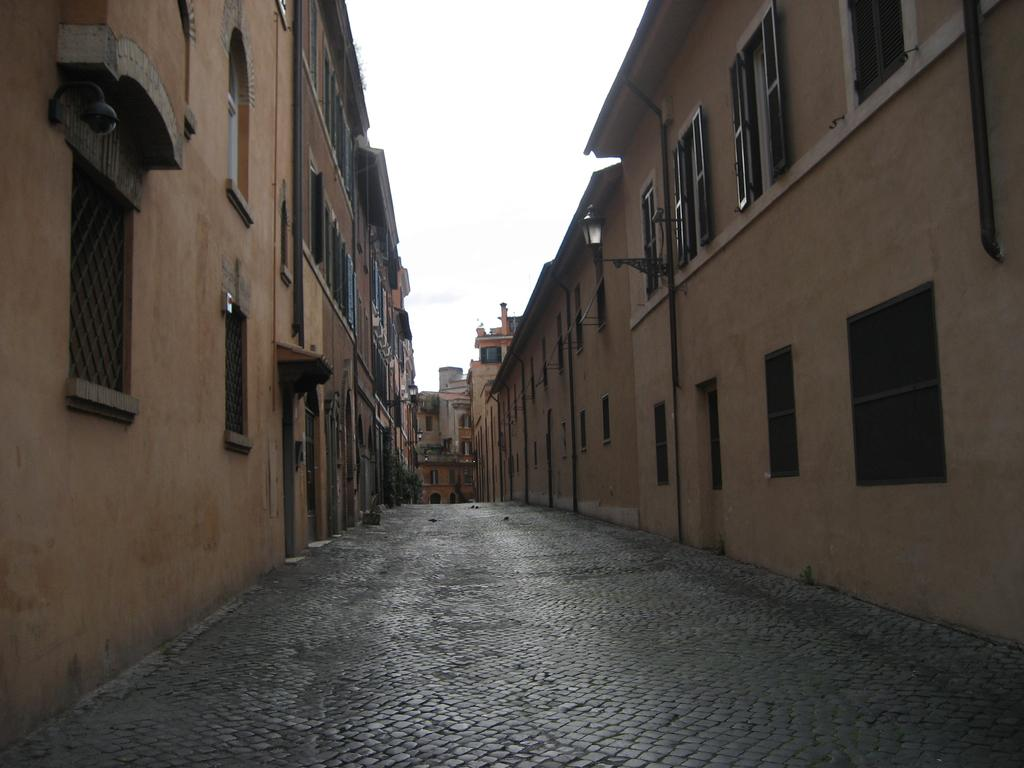What is the main subject of the image? The main subject of the image is many buildings. What specific feature can be observed on the buildings? The buildings have multiple windows. How many lights can be seen in the image? There are few lights visible in the image. What part of the natural environment is visible in the image? The sky is visible in the image. What type of duck can be seen swimming in the ground in the image? There is no duck or ground present in the image; it features multiple buildings with windows and a visible sky. 